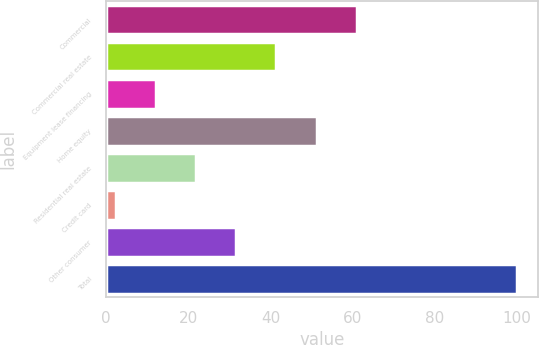<chart> <loc_0><loc_0><loc_500><loc_500><bar_chart><fcel>Commercial<fcel>Commercial real estate<fcel>Equipment lease financing<fcel>Home equity<fcel>Residential real estate<fcel>Credit card<fcel>Other consumer<fcel>Total<nl><fcel>60.96<fcel>41.44<fcel>12.16<fcel>51.2<fcel>21.92<fcel>2.4<fcel>31.68<fcel>100<nl></chart> 